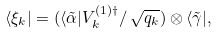Convert formula to latex. <formula><loc_0><loc_0><loc_500><loc_500>\langle \xi _ { k } | = ( { \langle \tilde { \alpha } | V _ { k } ^ { ( 1 ) \dagger } / \, { \sqrt { q _ { k } } } } ) \otimes \langle \tilde { \gamma } | ,</formula> 